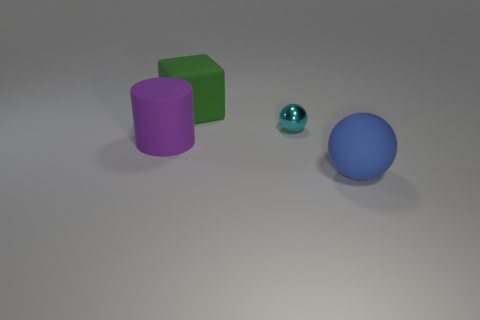There is a large ball; is it the same color as the sphere behind the big blue thing? No, the large ball in the foreground is blue, while the smaller sphere behind the larger blue ball has a teal hue, which is a blend of blue and green. 